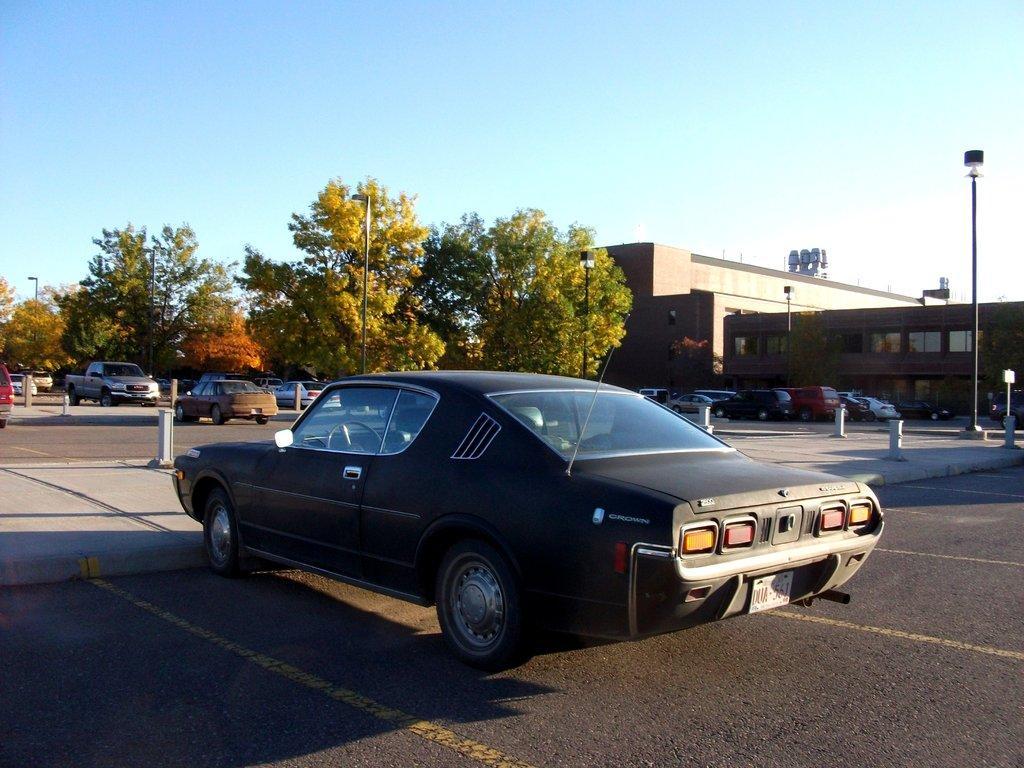How would you summarize this image in a sentence or two? As we can see in the image there are cars, buildings, trees, pole and sky. 